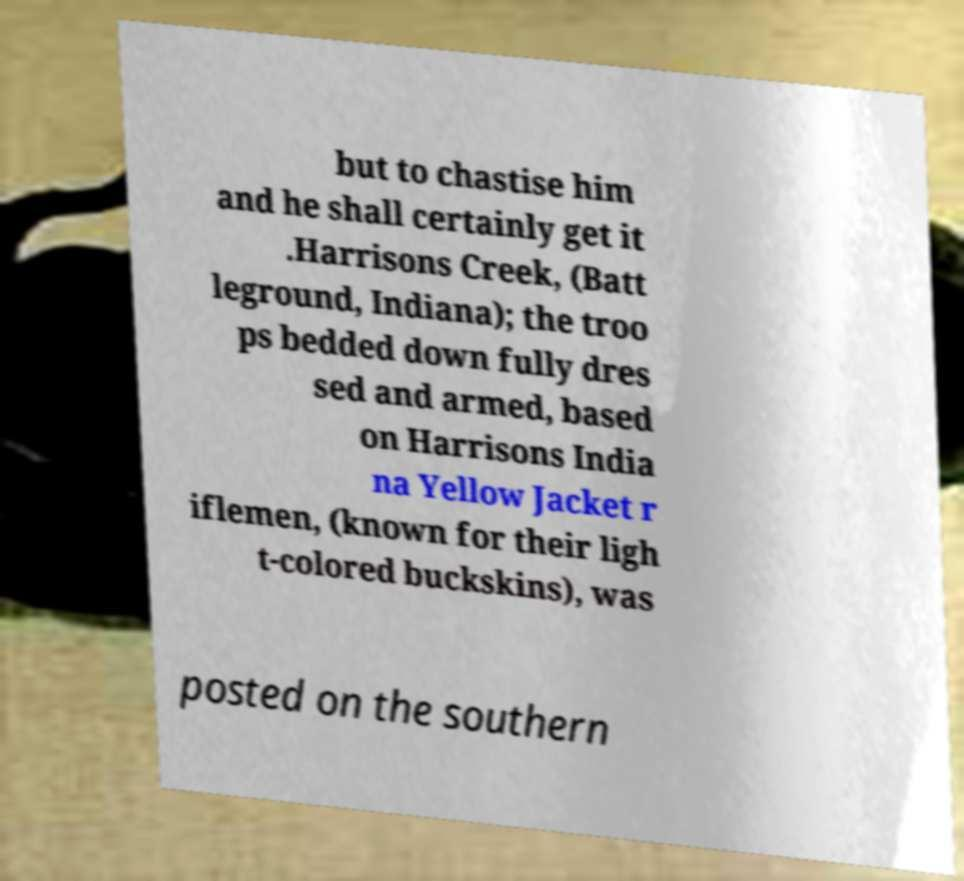For documentation purposes, I need the text within this image transcribed. Could you provide that? but to chastise him and he shall certainly get it .Harrisons Creek, (Batt leground, Indiana); the troo ps bedded down fully dres sed and armed, based on Harrisons India na Yellow Jacket r iflemen, (known for their ligh t-colored buckskins), was posted on the southern 